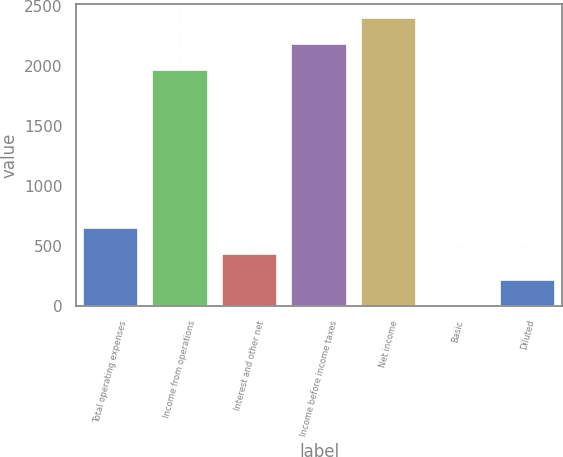Convert chart to OTSL. <chart><loc_0><loc_0><loc_500><loc_500><bar_chart><fcel>Total operating expenses<fcel>Income from operations<fcel>Interest and other net<fcel>Income before income taxes<fcel>Net income<fcel>Basic<fcel>Diluted<nl><fcel>648.33<fcel>1963<fcel>432.23<fcel>2179.1<fcel>2395.2<fcel>0.03<fcel>216.13<nl></chart> 